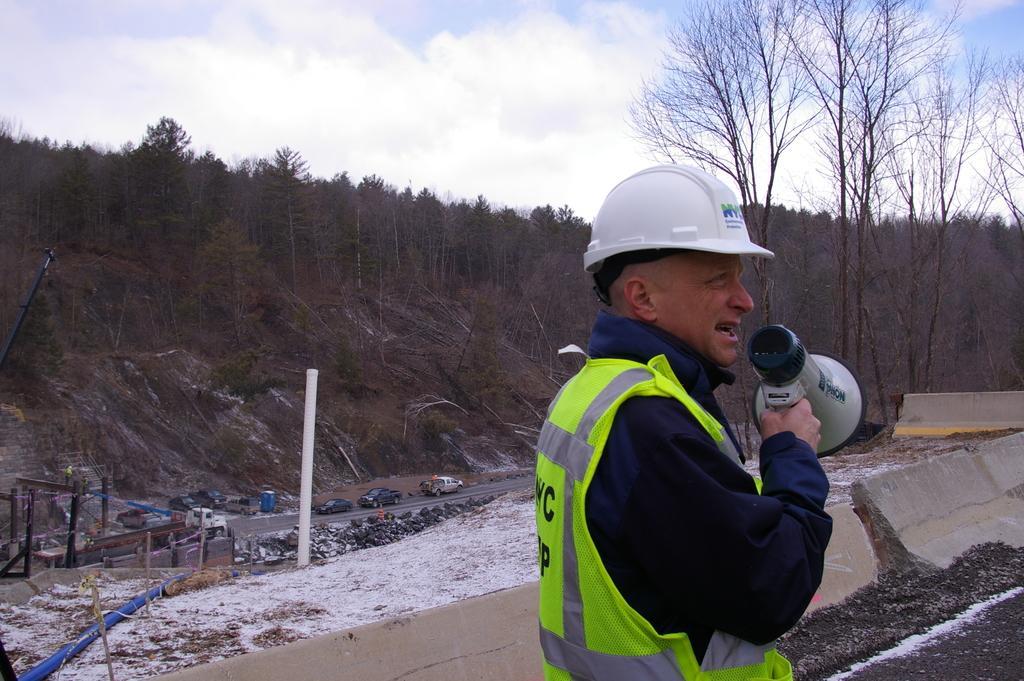How would you summarize this image in a sentence or two? In this image I can see a person wearing green color jacket and white color helmet and holding a mike and his mouth is open visible at the bottom , at the top I can see the sky and in the middle I can see trees and the road , on the road I can see vehicles and poles 